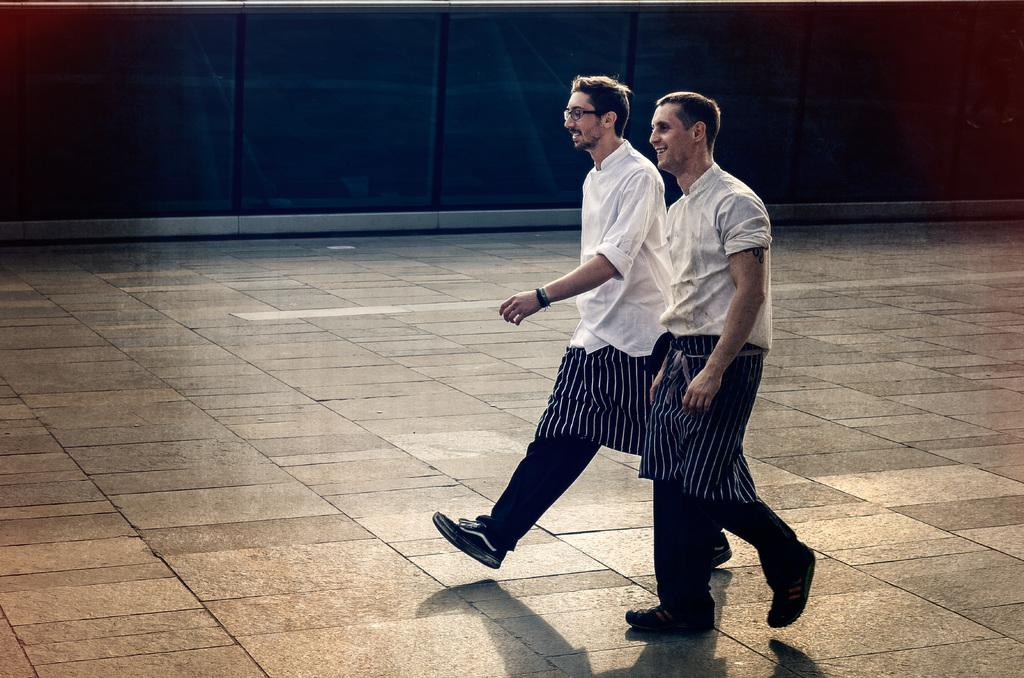What are the persons in the image doing? The persons in the image are walking. On what surface are the persons walking? The persons are walking on the ground. What can be seen in the background of the image? There is a wall in the background of the image. What type of cart is being pulled by the persons in the image? There is no cart present in the image; the persons are walking directly on the ground. 